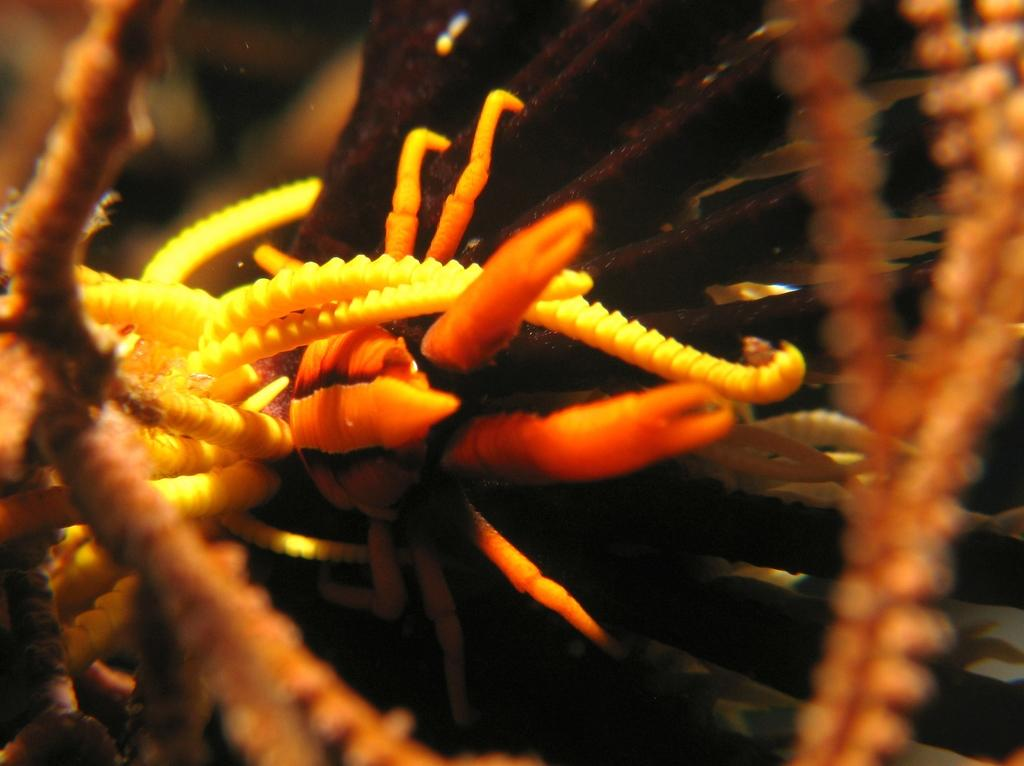What is the main subject of the image? There is an organism in the image. What number is written on the ball in the image? There is no ball present in the image, and therefore no number can be found on it. 